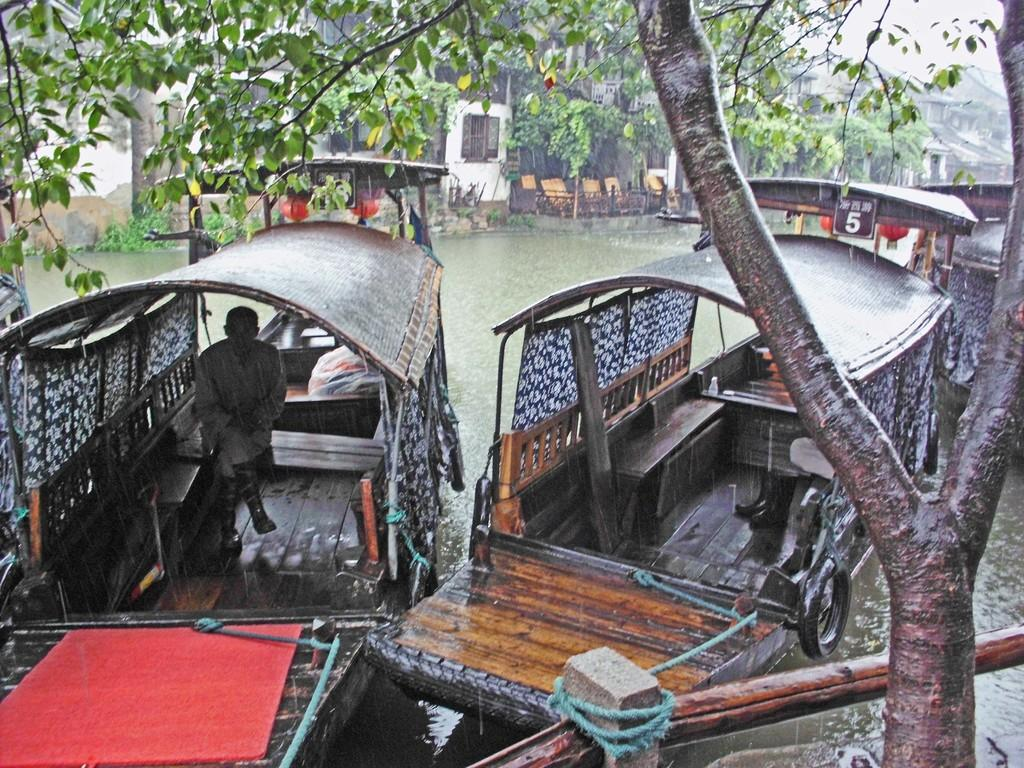What type of vehicles are in the water in the image? There are boats in the water in the image. What structures can be seen in the image? There are buildings visible in the image. What type of vegetation is present in the image? Trees are present in the image. What type of furniture is in the image? There are chairs in the image. What is the man in the image doing? The man is seated in one of the boats. What is the weather like in the image? It appears to be raining in the image. Where is the aunt standing in the image? There is no aunt present in the image. What type of crops can be seen growing in the field in the image? There is no field present in the image. What color is the hat worn by the man in the image? The man in the image is not wearing a hat. 